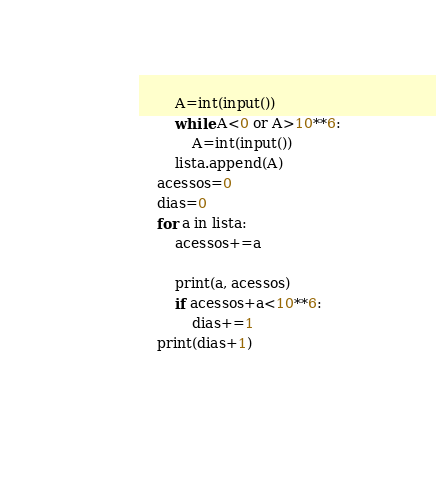Convert code to text. <code><loc_0><loc_0><loc_500><loc_500><_Python_>        A=int(input())
        while A<0 or A>10**6:
            A=int(input())
        lista.append(A)
    acessos=0
    dias=0
    for a in lista:
        acessos+=a
        
        print(a, acessos)
        if acessos+a<10**6:
            dias+=1
    print(dias+1)
        
    
</code> 